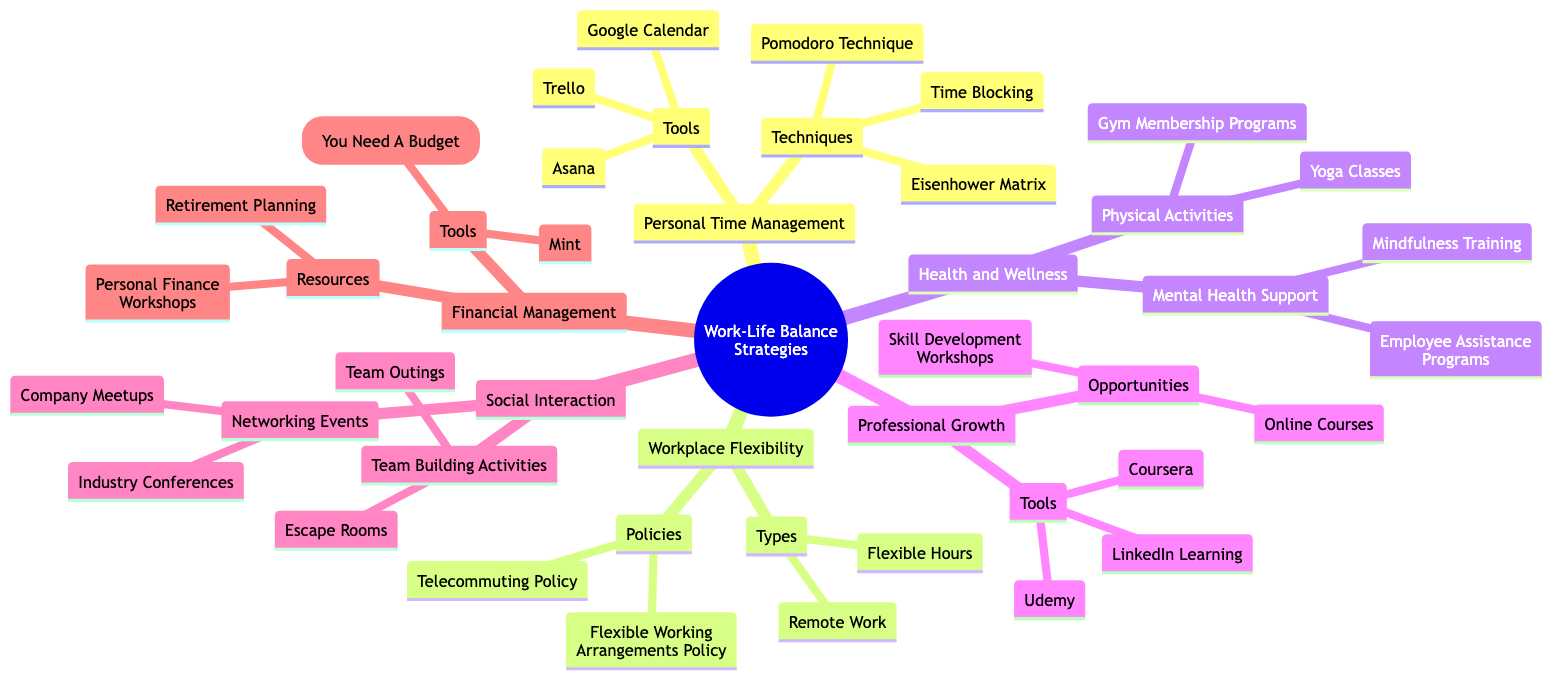What are the techniques listed under Personal Time Management? The diagram clearly states that the techniques available under Personal Time Management include the Pomodoro Technique, Time Blocking, and the Eisenhower Matrix. These are items categorized beneath the Personal Time Management node.
Answer: Pomodoro Technique, Time Blocking, Eisenhower Matrix How many types of Workplace Flexibility are there? The diagram specifies that there are two types of Workplace Flexibility: Remote Work and Flexible Hours. By counting these listed types, we determine the quantity.
Answer: 2 Which tool is mentioned for Financial Management? Looking at the Financial Management section of the diagram, it is evident that Mint and YNAB (You Need A Budget) are noted as tools. As the question requests a single tool, we will take one from this list.
Answer: Mint What policies are associated with Workplace Flexibility? The diagram indicates that there are two specific policies related to Workplace Flexibility: the Telecommuting Policy and the Flexible Working Arrangements Policy. By retrieving these items from the node, we can answer the query.
Answer: Telecommuting Policy, Flexible Working Arrangements Policy What is a health and wellness opportunity provided? The Health and Wellness section reveals Physical Activities focused on Gym Membership Programs and Yoga Classes. Given that the question is about an opportunity, we can identify one from this assortment.
Answer: Gym Membership Programs How is Mental Health Support categorized under Health and Wellness? The diagram shows that Mental Health Support falls under Health and Wellness itself, detailing specific support programs like Employee Assistance Programs and Mindfulness Training. Thus, Mental Health Support is classified under the broader category of Health and Wellness.
Answer: Mental Health Support What type of events are involved in Social Interaction? In the Social Interaction section, two categories are provided: Networking Events and Team Building Activities. These are the two kinds of interactions suggested for employees, allowing us to answer the question accordingly.
Answer: Networking Events, Team Building Activities What is the relationship between Professional Growth and Skill Development Workshops? The diagram indicates that Skill Development Workshops are an opportunity mentioned under the Professional Growth node. This establishes a direct relationship between the two terms, where one represents a specific category within the broader concept.
Answer: Opportunity 